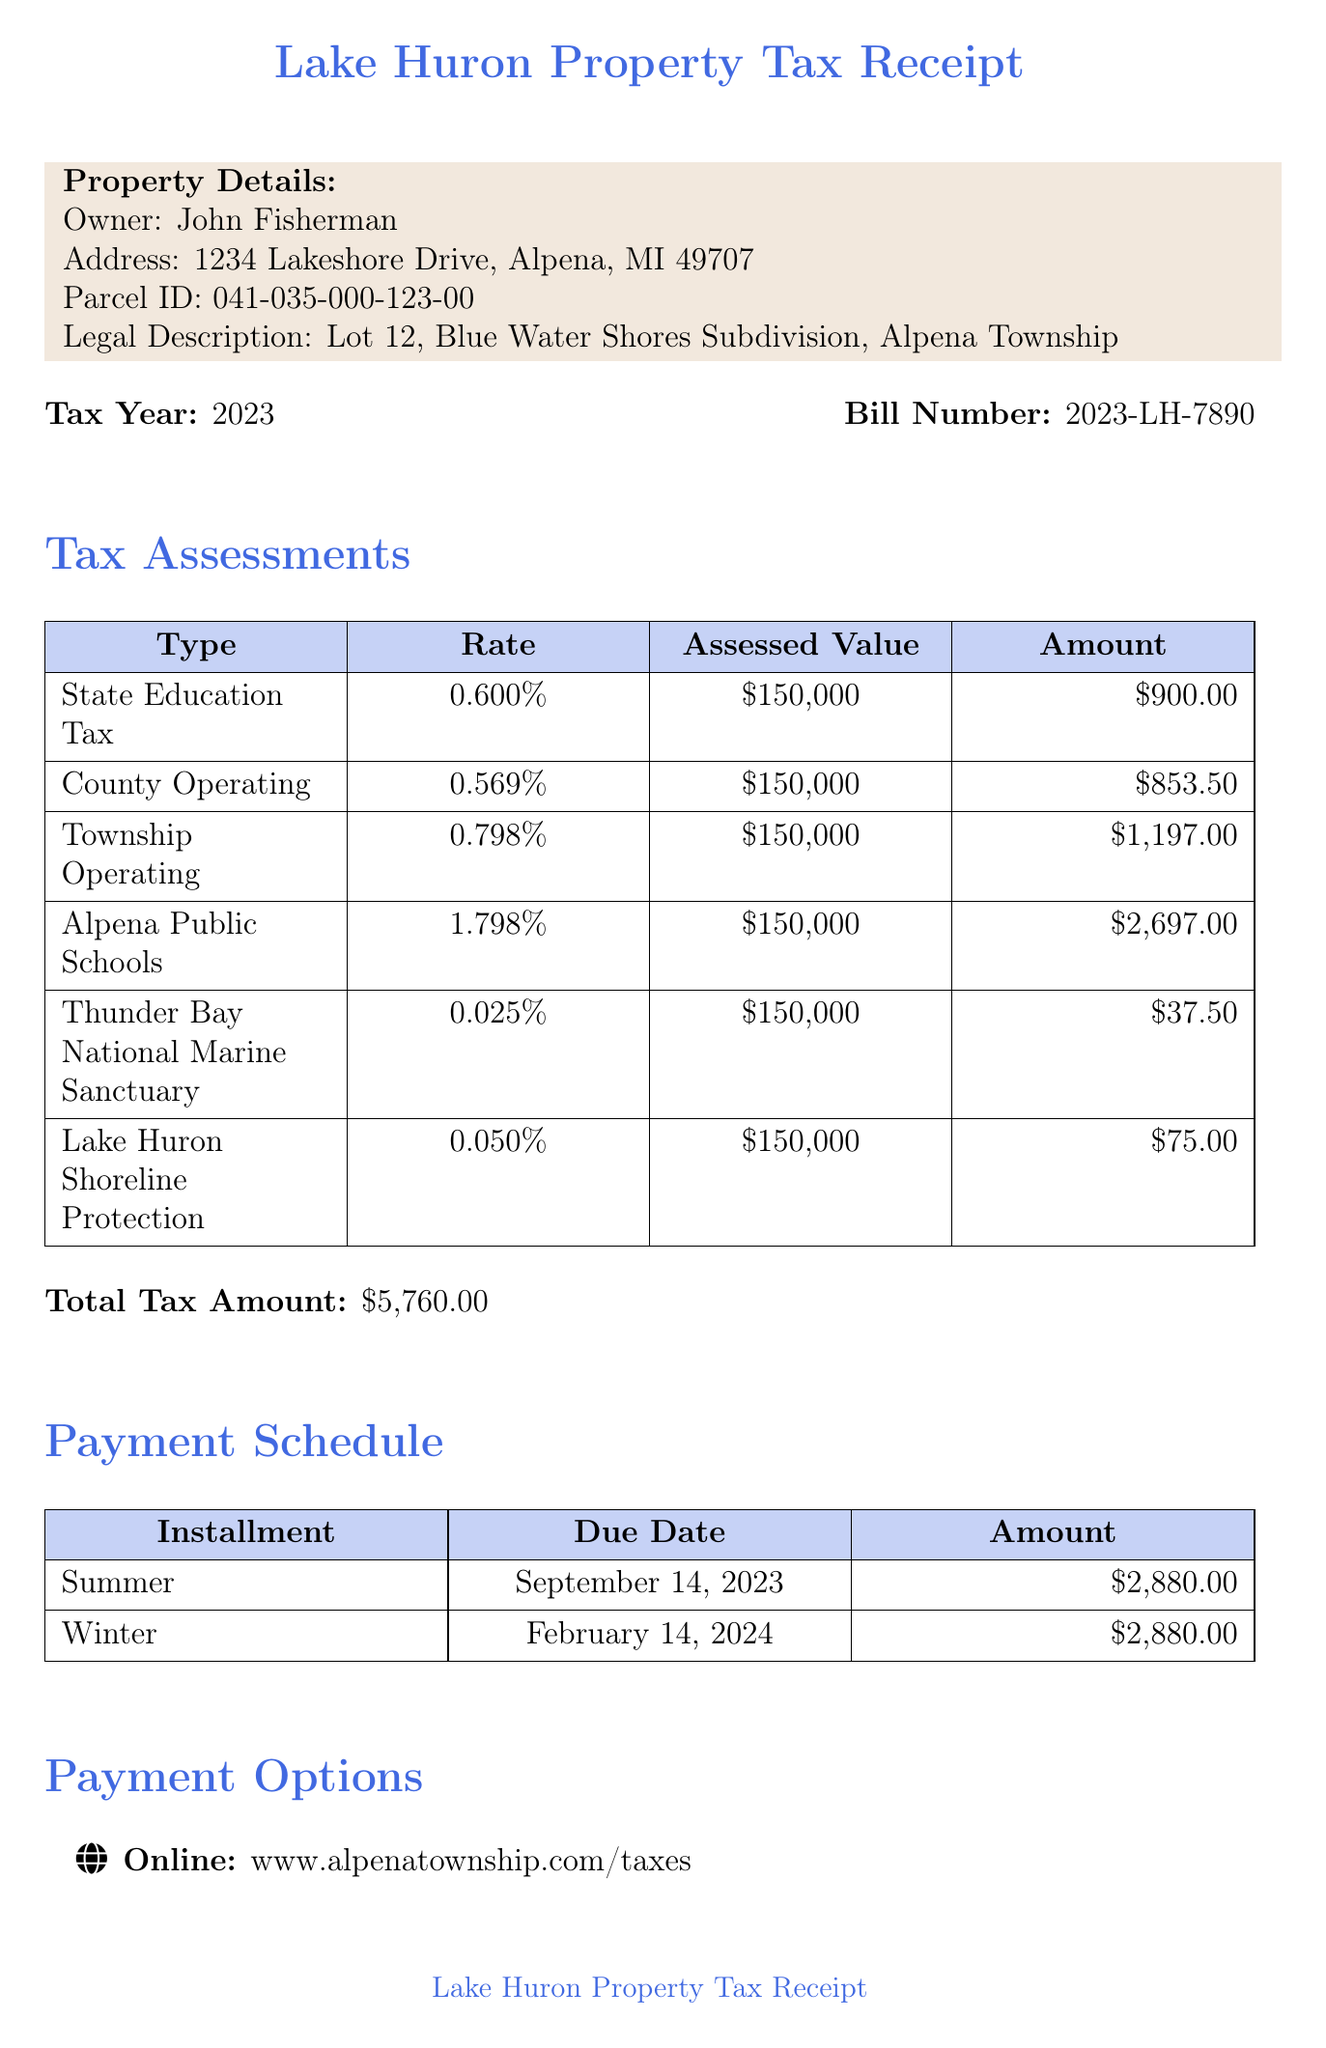What is the owner's name? The document provides the owner's name in the property details section, which is John Fisherman.
Answer: John Fisherman What is the total tax amount? The total tax amount is listed under the tax assessments section, which sums up to $5760.
Answer: $5760 What is the due date for the summer installment? The due date for the summer installment is found in the payment schedule section, which states September 14, 2023.
Answer: September 14, 2023 What is the assessed value of the property? The assessed value is mentioned in each assessment type, consistently mentioned as $150,000.
Answer: $150,000 What is the late payment penalty percentage? The late payment penalty is specified under additional information, stating it as 3% if paid after the due date.
Answer: 3% How many assessments are listed in the document? The document lists the assessments in the tax assessments section, with a total of six different types provided.
Answer: Six What is the contact number for the treasurer? The treasurer's contact number is included in the additional information section, noted as (989) 356-0297.
Answer: (989) 356-0297 What is the legal description of the property? The legal description of the property is detailed in the property details section as Lot 12, Blue Water Shores Subdivision, Alpena Township.
Answer: Lot 12, Blue Water Shores Subdivision, Alpena Township When is the tax tribunal deadline? The tax tribunal deadline is mentioned in the additional information, specifically marked as July 31, 2023.
Answer: July 31, 2023 